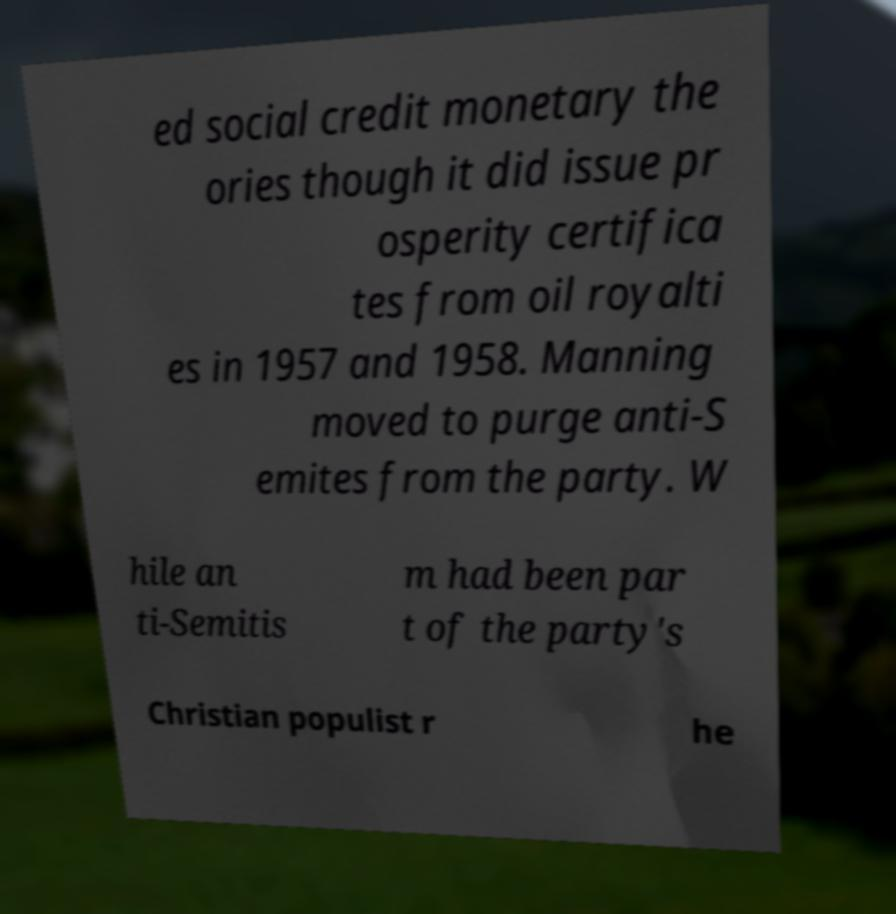There's text embedded in this image that I need extracted. Can you transcribe it verbatim? ed social credit monetary the ories though it did issue pr osperity certifica tes from oil royalti es in 1957 and 1958. Manning moved to purge anti-S emites from the party. W hile an ti-Semitis m had been par t of the party's Christian populist r he 